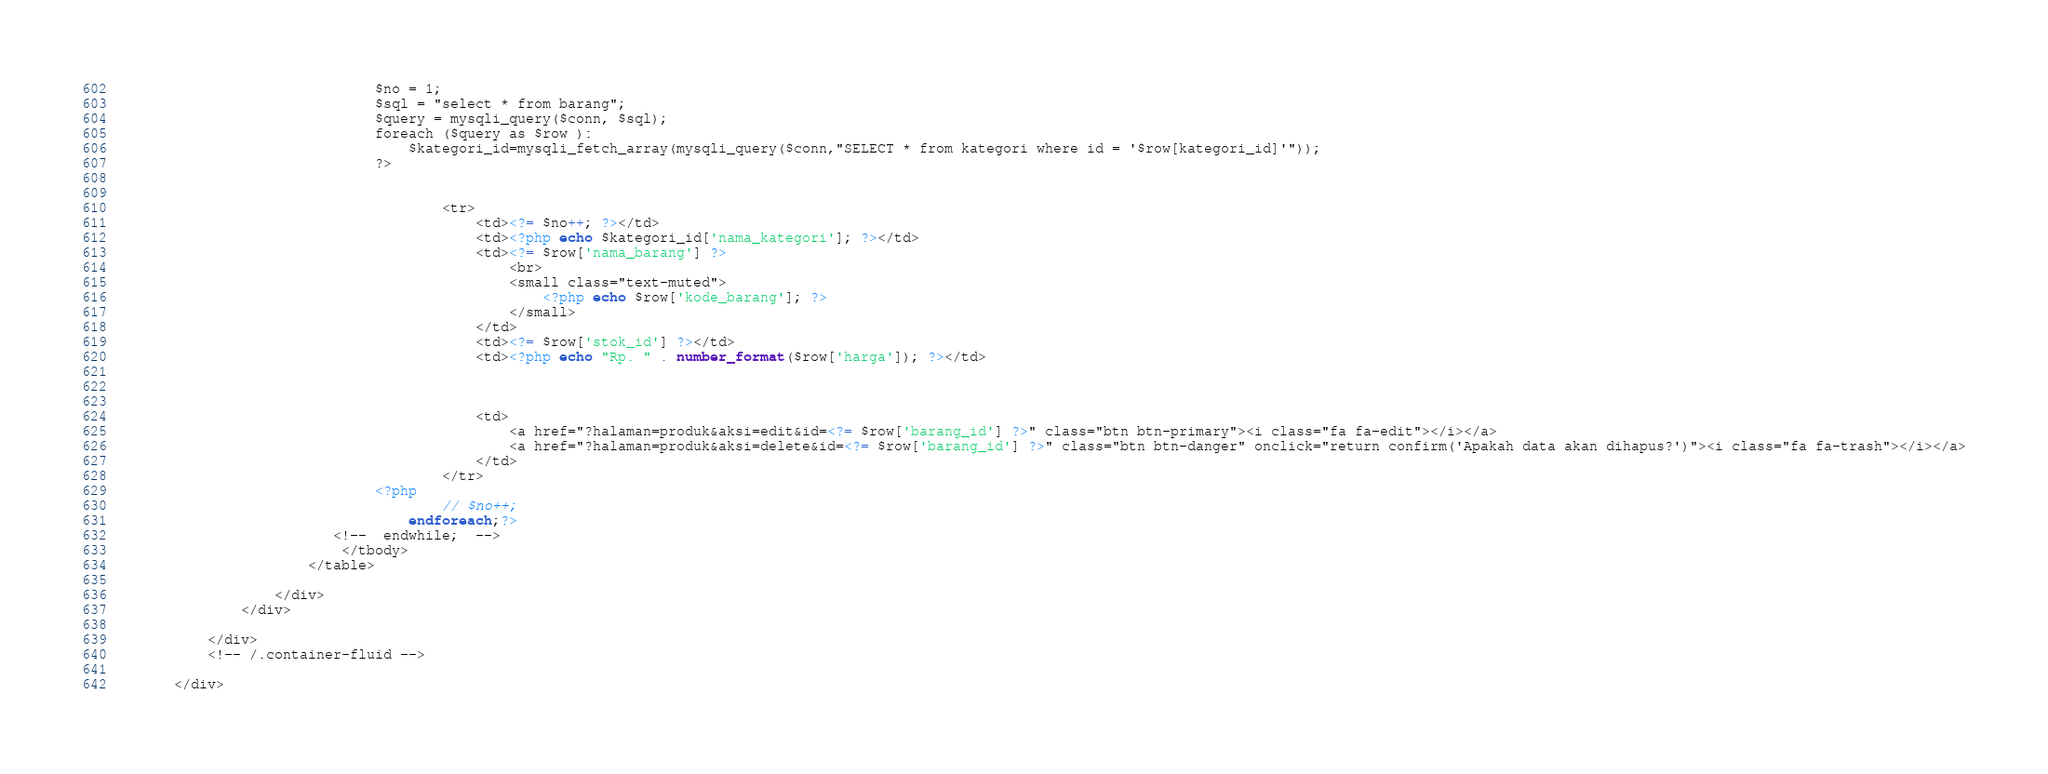<code> <loc_0><loc_0><loc_500><loc_500><_PHP_>                                $no = 1;
                                $sql = "select * from barang";
                                $query = mysqli_query($conn, $sql);
                                foreach ($query as $row ):
                                    $kategori_id=mysqli_fetch_array(mysqli_query($conn,"SELECT * from kategori where id = '$row[kategori_id]'")); 
                                ?>
                                
                                    
                                        <tr>
                                            <td><?= $no++; ?></td>
                                            <td><?php echo $kategori_id['nama_kategori']; ?></td>
                                            <td><?= $row['nama_barang'] ?>
                                                <br>
                                                <small class="text-muted">
                                                    <?php echo $row['kode_barang']; ?>
                                                </small>
                                            </td>
                                            <td><?= $row['stok_id'] ?></td>
                                            <td><?php echo "Rp. " . number_format($row['harga']); ?></td>
                                            


                                            <td>
                                                <a href="?halaman=produk&aksi=edit&id=<?= $row['barang_id'] ?>" class="btn btn-primary"><i class="fa fa-edit"></i></a>
                                                <a href="?halaman=produk&aksi=delete&id=<?= $row['barang_id'] ?>" class="btn btn-danger" onclick="return confirm('Apakah data akan dihapus?')"><i class="fa fa-trash"></i></a>
                                            </td>
                                        </tr>
                                <?php
                                        // $no++;
                                    endforeach;?>
                           <!--  endwhile;  -->
                            </tbody>
                        </table>

                    </div>
                </div>

            </div>
            <!-- /.container-fluid -->

        </div></code> 